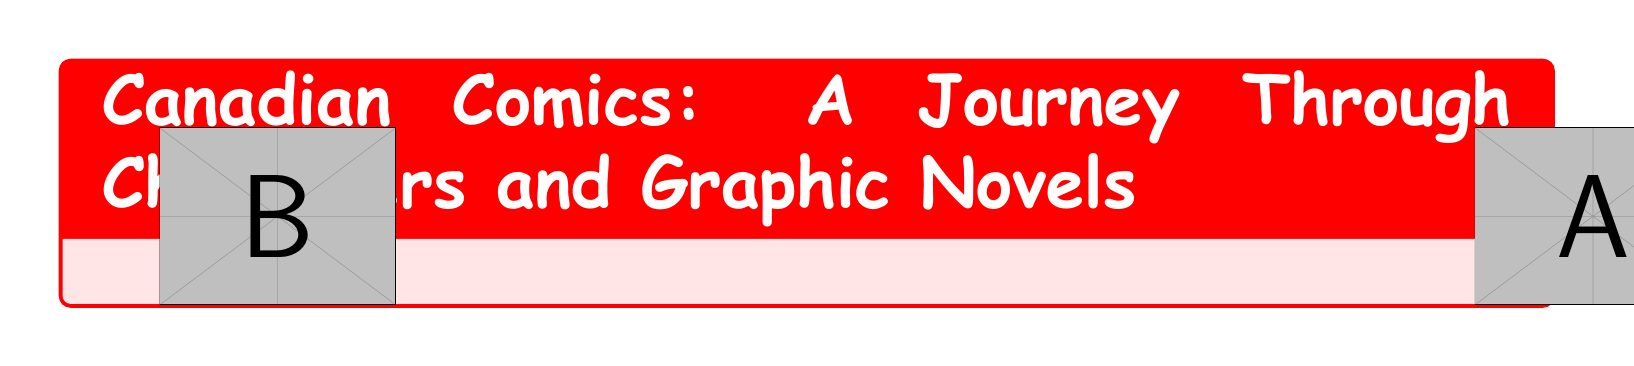What is the year Captain Canuck was created? Captain Canuck was created in 1975, as mentioned in the featured characters section of the document.
Answer: 1975 Who is the creator of Essex County? Essex County is written by Jeff Lemire, as stated in the notable graphic novels section.
Answer: Jeff Lemire What notable feature does Nelvana of the Northern Lights possess? Nelvana of the Northern Lights has flight and invisibility powers, which are described in the featured characters section.
Answer: Flight and invisibility What is the genre of Scott Pilgrim? The document describes Scott Pilgrim as blending video game culture with coming-of-age themes, indicating its genre.
Answer: Coming-of-age What year marks the revival of the Canadian comic book industry? The revival occurred in 1970, as highlighted in the timeline section.
Answer: 1970 Which publisher is associated with Drawn & Quarterly? Drawn & Quarterly is listed under Canadian comic publishers in the document.
Answer: Drawn & Quarterly How is Seth's artwork described? The document describes Seth's artwork as nostalgic and melancholic, reflecting mid-20th century Canadian life.
Answer: Nostalgic, melancholic What was a significant event in 2000? In 2000, there was a rise of webcomics and independent publishers, noted in the timeline highlights.
Answer: Rise of webcomics Which character was one of the first female superheroes? Nelvana of the Northern Lights is noted as one of the first female superheroes in the document.
Answer: Nelvana of the Northern Lights 